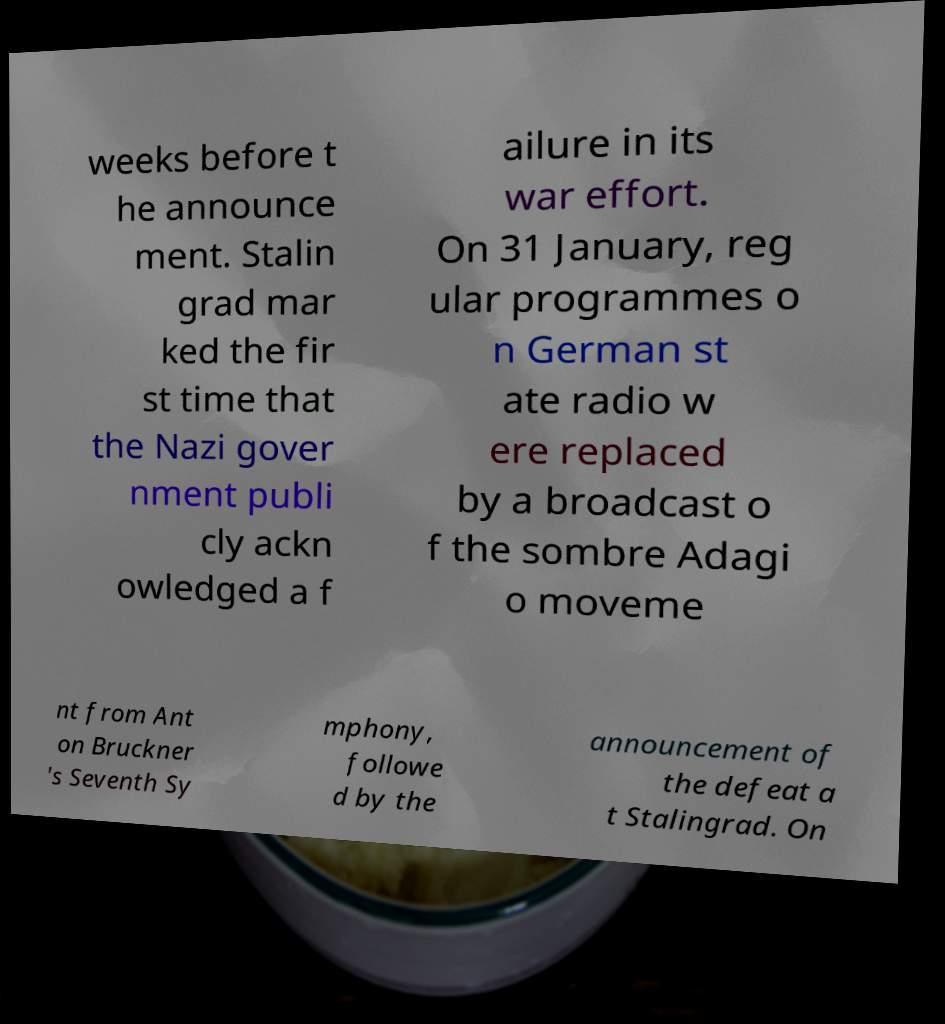There's text embedded in this image that I need extracted. Can you transcribe it verbatim? weeks before t he announce ment. Stalin grad mar ked the fir st time that the Nazi gover nment publi cly ackn owledged a f ailure in its war effort. On 31 January, reg ular programmes o n German st ate radio w ere replaced by a broadcast o f the sombre Adagi o moveme nt from Ant on Bruckner 's Seventh Sy mphony, followe d by the announcement of the defeat a t Stalingrad. On 